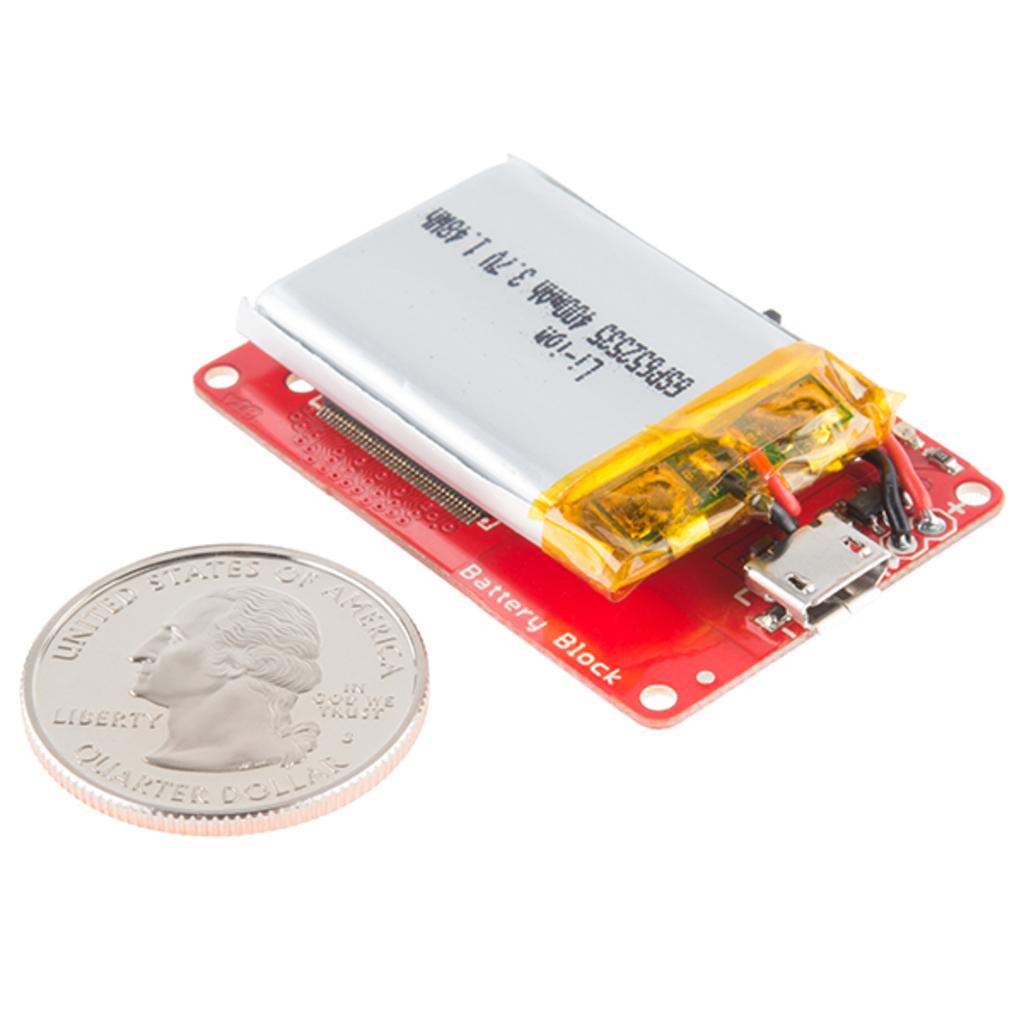What is this chip for?
Keep it short and to the point. Battery block. What is the coin?
Offer a very short reply. Quarter. 